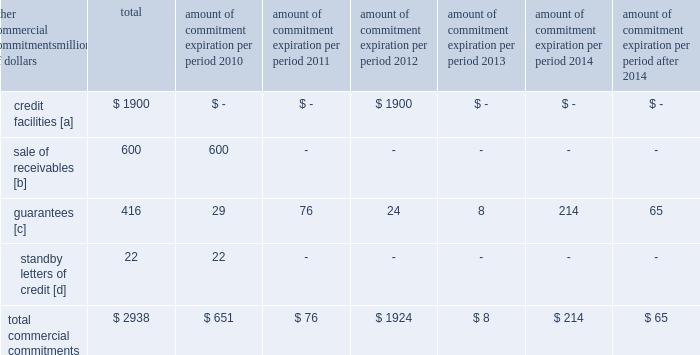Amount of commitment expiration per period other commercial commitments after millions of dollars total 2010 2011 2012 2013 2014 2014 .
[a] none of the credit facility was used as of december 31 , 2009 .
[b] $ 400 million of the sale of receivables program was utilized at december 31 , 2009 .
[c] includes guaranteed obligations related to our headquarters building , equipment financings , and affiliated operations .
[d] none of the letters of credit were drawn upon as of december 31 , 2009 .
Off-balance sheet arrangements sale of receivables 2013 the railroad transfers most of its accounts receivable to union pacific receivables , inc .
( upri ) , a bankruptcy-remote subsidiary , as part of a sale of receivables facility .
Upri sells , without recourse on a 364-day revolving basis , an undivided interest in such accounts receivable to investors .
The total capacity to sell undivided interests to investors under the facility was $ 600 million and $ 700 million at december 31 , 2009 and 2008 , respectively .
The value of the outstanding undivided interest held by investors under the facility was $ 400 million and $ 584 million at december 31 , 2009 and 2008 , respectively .
During 2009 , upri reduced the outstanding undivided interest held by investors due to a decrease in available receivables .
The value of the undivided interest held by investors is not included in our consolidated financial statements .
The value of the undivided interest held by investors was supported by $ 817 million and $ 1015 million of accounts receivable held by upri at december 31 , 2009 and 2008 , respectively .
At december 31 , 2009 and 2008 , the value of the interest retained by upri was $ 417 million and $ 431 million , respectively .
This retained interest is included in accounts receivable in our consolidated financial statements .
The interest sold to investors is sold at carrying value , which approximates fair value , and there is no gain or loss recognized from the transaction .
The value of the outstanding undivided interest held by investors could fluctuate based upon the availability of eligible receivables and is directly affected by changing business volumes and credit risks , including default and dilution .
If default or dilution ratios increase one percent , the value of the outstanding undivided interest held by investors would not change as of december 31 , 2009 .
Should our credit rating fall below investment grade , the value of the outstanding undivided interest held by investors would be reduced , and , in certain cases , the investors would have the right to discontinue the facility .
The railroad services the sold receivables ; however , the railroad does not recognize any servicing asset or liability , as the servicing fees adequately compensate us for these responsibilities .
The railroad collected approximately $ 13.8 billion and $ 17.8 billion during the years ended december 31 , 2009 and 2008 , respectively .
Upri used certain of these proceeds to purchase new receivables under the facility .
The costs of the sale of receivables program are included in other income and were $ 9 million , $ 23 million , and $ 35 million for 2009 , 2008 , and 2007 , respectively .
The costs include interest , which will vary based on prevailing commercial paper rates , program fees paid to banks , commercial paper issuing costs , and fees for unused commitment availability .
The decrease in the 2009 costs was primarily attributable to lower commercial paper rates and a decrease in the outstanding interest held by investors. .
What percentage of total commercial commitments are sale of receivables? 
Computations: (600 / 2938)
Answer: 0.20422. 